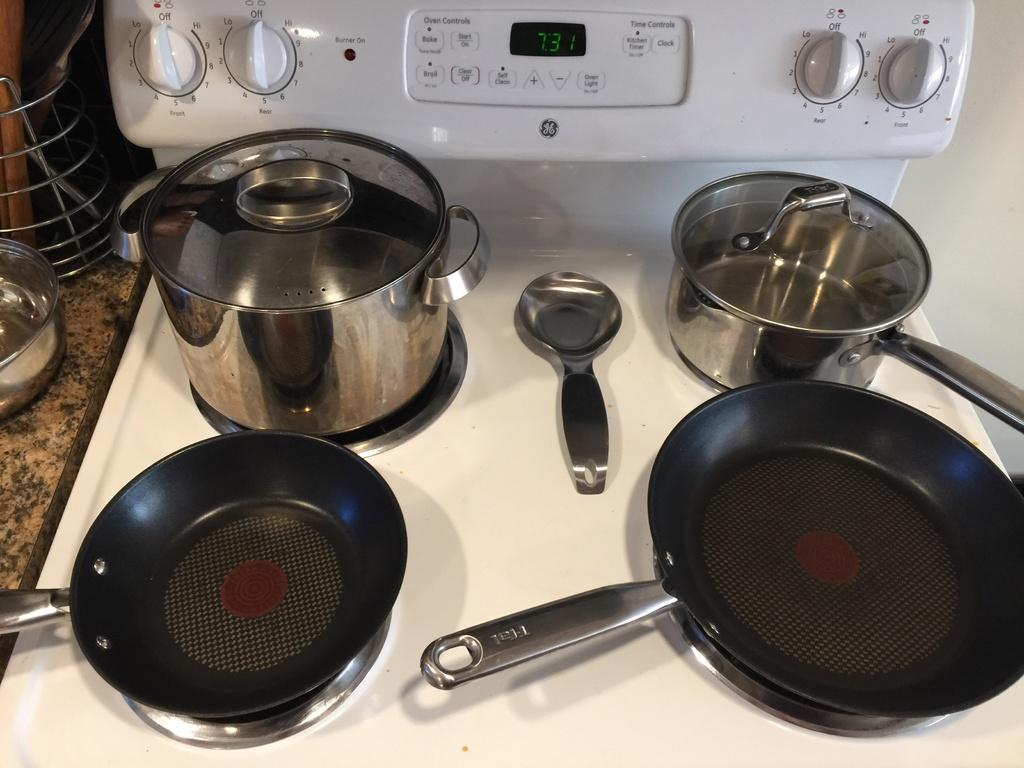<image>
Give a short and clear explanation of the subsequent image. Two pots and two skillets are on a GE stove. 